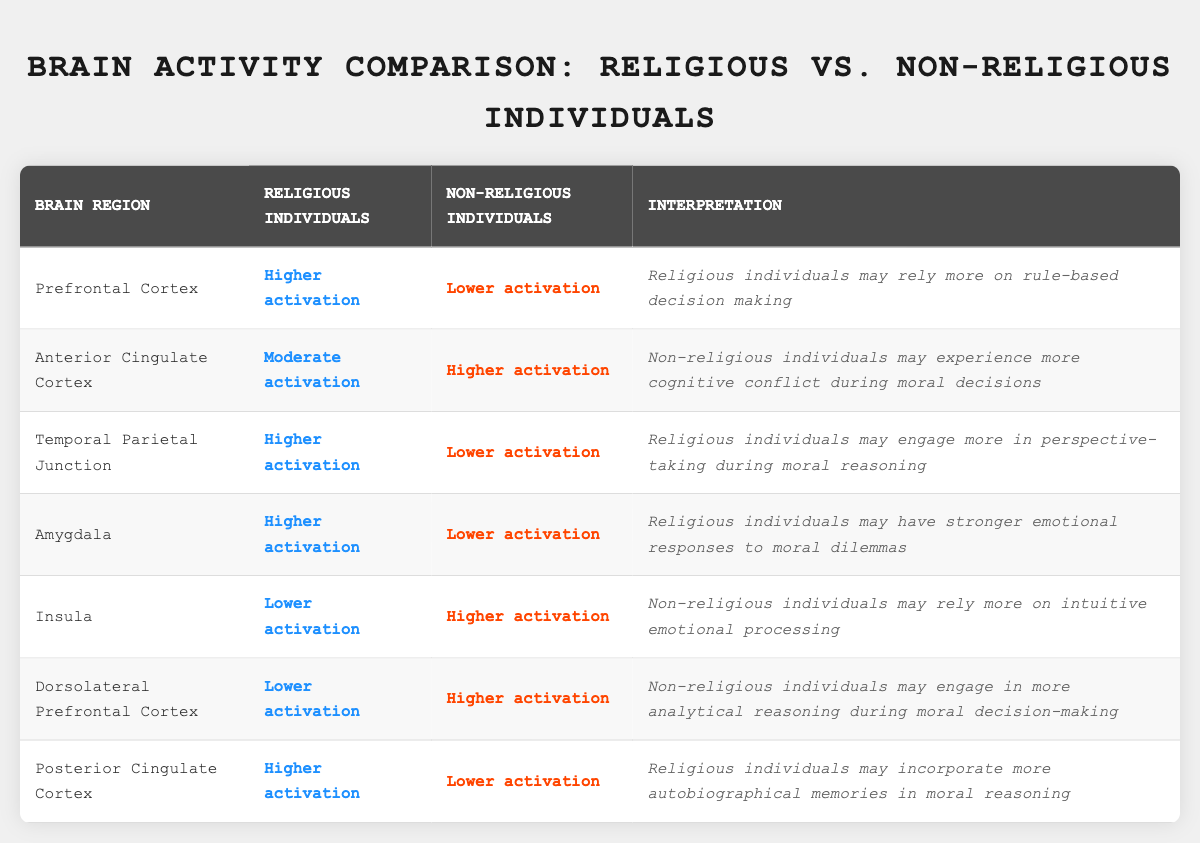What brain region shows higher activation in religious individuals? The table states that the Prefrontal Cortex, Temporal Parietal Junction, Amygdala, and Posterior Cingulate Cortex all show higher activation in religious individuals.
Answer: Prefrontal Cortex, Temporal Parietal Junction, Amygdala, Posterior Cingulate Cortex Which brain region indicates lower activation for non-religious individuals? The Insula and Dorsolateral Prefrontal Cortex show lower activation for religious individuals compared to non-religious individuals in the table.
Answer: Insula, Dorsolateral Prefrontal Cortex Are religious individuals likely to engage in more analytical reasoning during moral decision-making? According to the table, the Dorsolateral Prefrontal Cortex shows lower activation in religious individuals and higher in non-religious individuals, suggesting they engage more in analytical reasoning.
Answer: No What is the interpretation for the Anterior Cingulate Cortex regarding non-religious individuals? The table states that non-religious individuals experience higher activation in the Anterior Cingulate Cortex, indicating that they may experience more cognitive conflict during moral decisions.
Answer: Non-religious individuals may experience more cognitive conflict during moral decisions Which group has higher activation in the Amygdala when facing moral dilemmas? The table specifies that religious individuals have higher activation in the Amygdala, suggesting they may have stronger emotional responses to moral dilemmas.
Answer: Religious individuals How does the activation of the Insula compare between the two groups? The Insula shows lower activation in religious individuals and higher in non-religious individuals; thus, non-religious individuals rely more on intuitive emotional processing.
Answer: Lower in religious individuals, higher in non-religious individuals If we consider the Prefrontal Cortex and Dorsolateral Prefrontal Cortex together, in which group is the overall activation level higher? The Prefrontal Cortex is higher in religious individuals while the Dorsolateral Prefrontal Cortex is lower in religious individuals. To summarize, religious individuals show higher activation in one but not the other; thus, we cannot definitively say their overall level is higher without further data.
Answer: Cannot determine What brain region is associated with autobiographical memories in religious individuals? The table indicates that the Posterior Cingulate Cortex has higher activation in religious individuals, which is associated with incorporating more autobiographical memories in moral reasoning.
Answer: Posterior Cingulate Cortex 